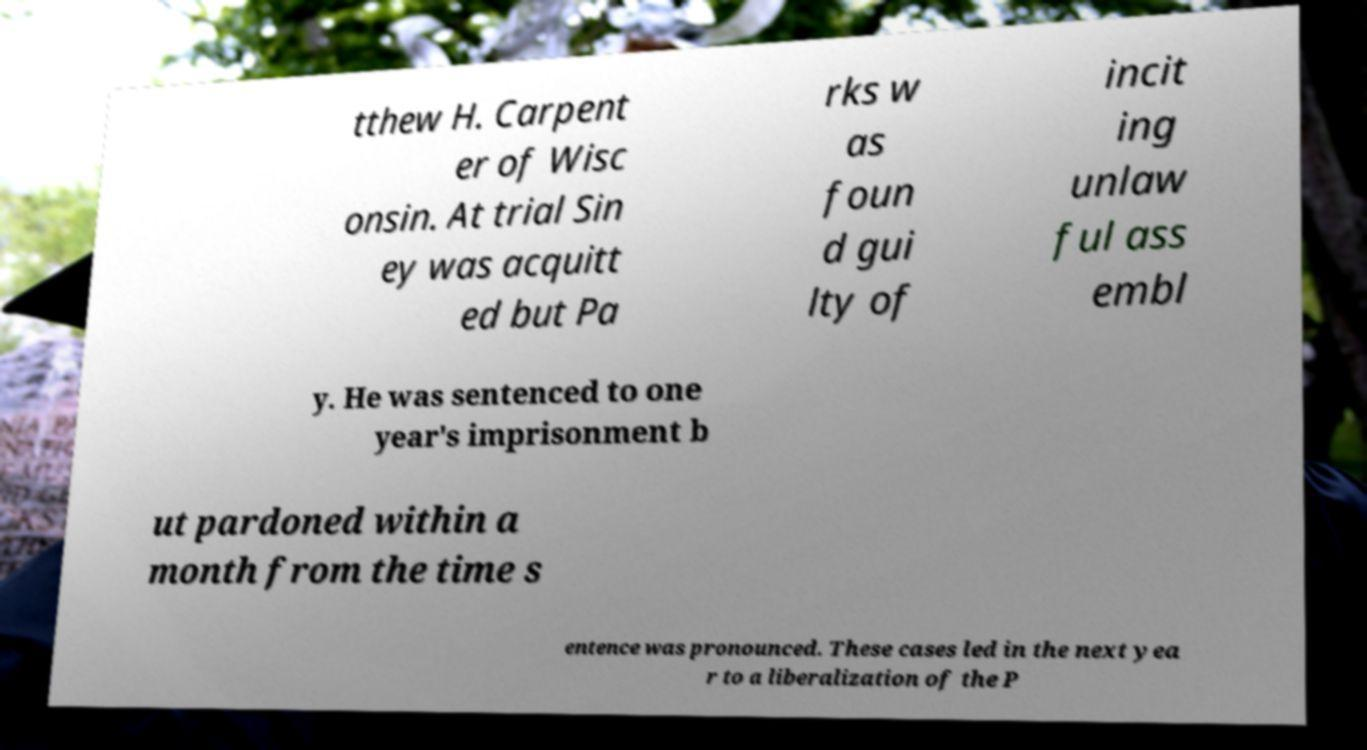What messages or text are displayed in this image? I need them in a readable, typed format. tthew H. Carpent er of Wisc onsin. At trial Sin ey was acquitt ed but Pa rks w as foun d gui lty of incit ing unlaw ful ass embl y. He was sentenced to one year's imprisonment b ut pardoned within a month from the time s entence was pronounced. These cases led in the next yea r to a liberalization of the P 